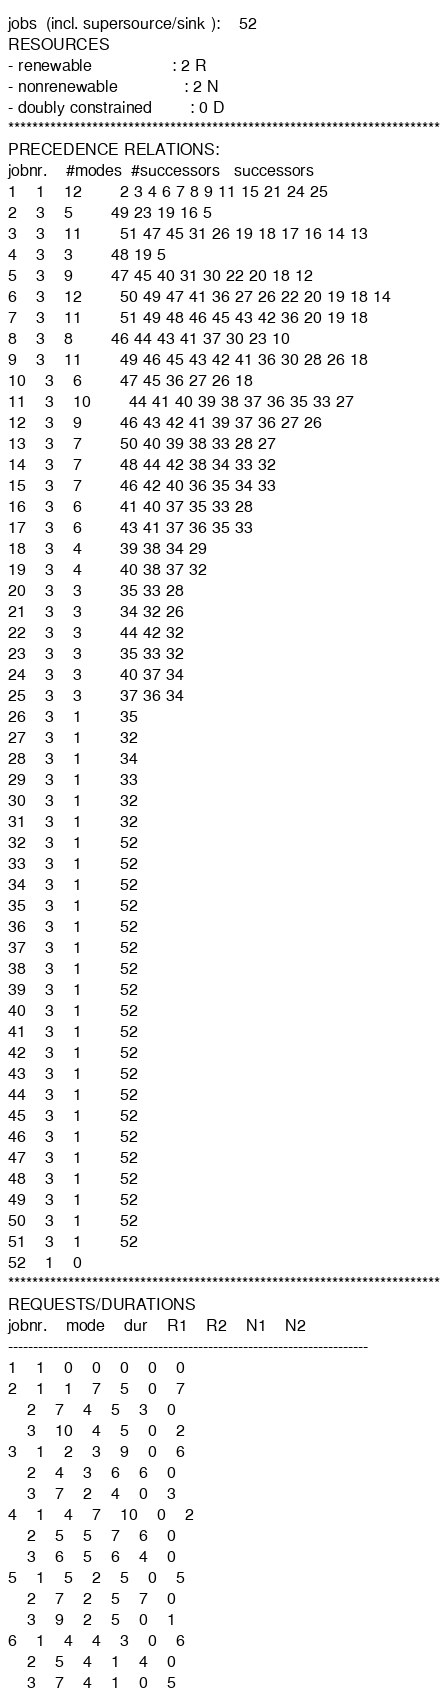<code> <loc_0><loc_0><loc_500><loc_500><_ObjectiveC_>jobs  (incl. supersource/sink ):	52
RESOURCES
- renewable                 : 2 R
- nonrenewable              : 2 N
- doubly constrained        : 0 D
************************************************************************
PRECEDENCE RELATIONS:
jobnr.    #modes  #successors   successors
1	1	12		2 3 4 6 7 8 9 11 15 21 24 25 
2	3	5		49 23 19 16 5 
3	3	11		51 47 45 31 26 19 18 17 16 14 13 
4	3	3		48 19 5 
5	3	9		47 45 40 31 30 22 20 18 12 
6	3	12		50 49 47 41 36 27 26 22 20 19 18 14 
7	3	11		51 49 48 46 45 43 42 36 20 19 18 
8	3	8		46 44 43 41 37 30 23 10 
9	3	11		49 46 45 43 42 41 36 30 28 26 18 
10	3	6		47 45 36 27 26 18 
11	3	10		44 41 40 39 38 37 36 35 33 27 
12	3	9		46 43 42 41 39 37 36 27 26 
13	3	7		50 40 39 38 33 28 27 
14	3	7		48 44 42 38 34 33 32 
15	3	7		46 42 40 36 35 34 33 
16	3	6		41 40 37 35 33 28 
17	3	6		43 41 37 36 35 33 
18	3	4		39 38 34 29 
19	3	4		40 38 37 32 
20	3	3		35 33 28 
21	3	3		34 32 26 
22	3	3		44 42 32 
23	3	3		35 33 32 
24	3	3		40 37 34 
25	3	3		37 36 34 
26	3	1		35 
27	3	1		32 
28	3	1		34 
29	3	1		33 
30	3	1		32 
31	3	1		32 
32	3	1		52 
33	3	1		52 
34	3	1		52 
35	3	1		52 
36	3	1		52 
37	3	1		52 
38	3	1		52 
39	3	1		52 
40	3	1		52 
41	3	1		52 
42	3	1		52 
43	3	1		52 
44	3	1		52 
45	3	1		52 
46	3	1		52 
47	3	1		52 
48	3	1		52 
49	3	1		52 
50	3	1		52 
51	3	1		52 
52	1	0		
************************************************************************
REQUESTS/DURATIONS
jobnr.	mode	dur	R1	R2	N1	N2	
------------------------------------------------------------------------
1	1	0	0	0	0	0	
2	1	1	7	5	0	7	
	2	7	4	5	3	0	
	3	10	4	5	0	2	
3	1	2	3	9	0	6	
	2	4	3	6	6	0	
	3	7	2	4	0	3	
4	1	4	7	10	0	2	
	2	5	5	7	6	0	
	3	6	5	6	4	0	
5	1	5	2	5	0	5	
	2	7	2	5	7	0	
	3	9	2	5	0	1	
6	1	4	4	3	0	6	
	2	5	4	1	4	0	
	3	7	4	1	0	5	</code> 